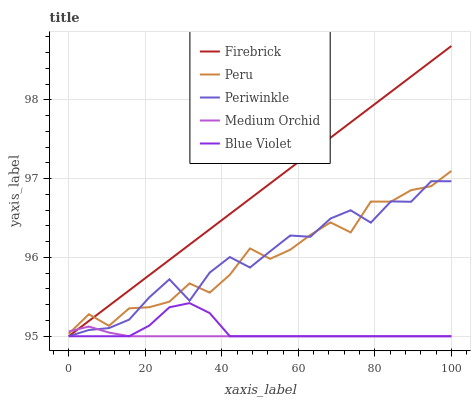Does Medium Orchid have the minimum area under the curve?
Answer yes or no. Yes. Does Firebrick have the maximum area under the curve?
Answer yes or no. Yes. Does Periwinkle have the minimum area under the curve?
Answer yes or no. No. Does Periwinkle have the maximum area under the curve?
Answer yes or no. No. Is Firebrick the smoothest?
Answer yes or no. Yes. Is Periwinkle the roughest?
Answer yes or no. Yes. Is Medium Orchid the smoothest?
Answer yes or no. No. Is Medium Orchid the roughest?
Answer yes or no. No. Does Firebrick have the lowest value?
Answer yes or no. Yes. Does Peru have the lowest value?
Answer yes or no. No. Does Firebrick have the highest value?
Answer yes or no. Yes. Does Periwinkle have the highest value?
Answer yes or no. No. Is Blue Violet less than Peru?
Answer yes or no. Yes. Is Peru greater than Blue Violet?
Answer yes or no. Yes. Does Blue Violet intersect Medium Orchid?
Answer yes or no. Yes. Is Blue Violet less than Medium Orchid?
Answer yes or no. No. Is Blue Violet greater than Medium Orchid?
Answer yes or no. No. Does Blue Violet intersect Peru?
Answer yes or no. No. 